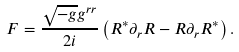<formula> <loc_0><loc_0><loc_500><loc_500>\ F = \frac { \sqrt { - g } g ^ { r r } } { 2 i } \left ( R ^ { \ast } \partial _ { r } R - R \partial _ { r } R ^ { \ast } \right ) .</formula> 